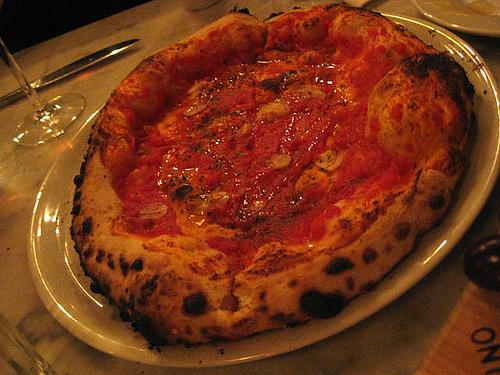Is this fine dining?
Write a very short answer. No. What type of food is on the plate?
Keep it brief. Pizza. What color is the plate?
Concise answer only. White. 